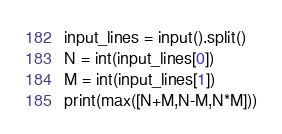Convert code to text. <code><loc_0><loc_0><loc_500><loc_500><_Python_>
input_lines = input().split()
N = int(input_lines[0])
M = int(input_lines[1])
print(max([N+M,N-M,N*M]))
</code> 